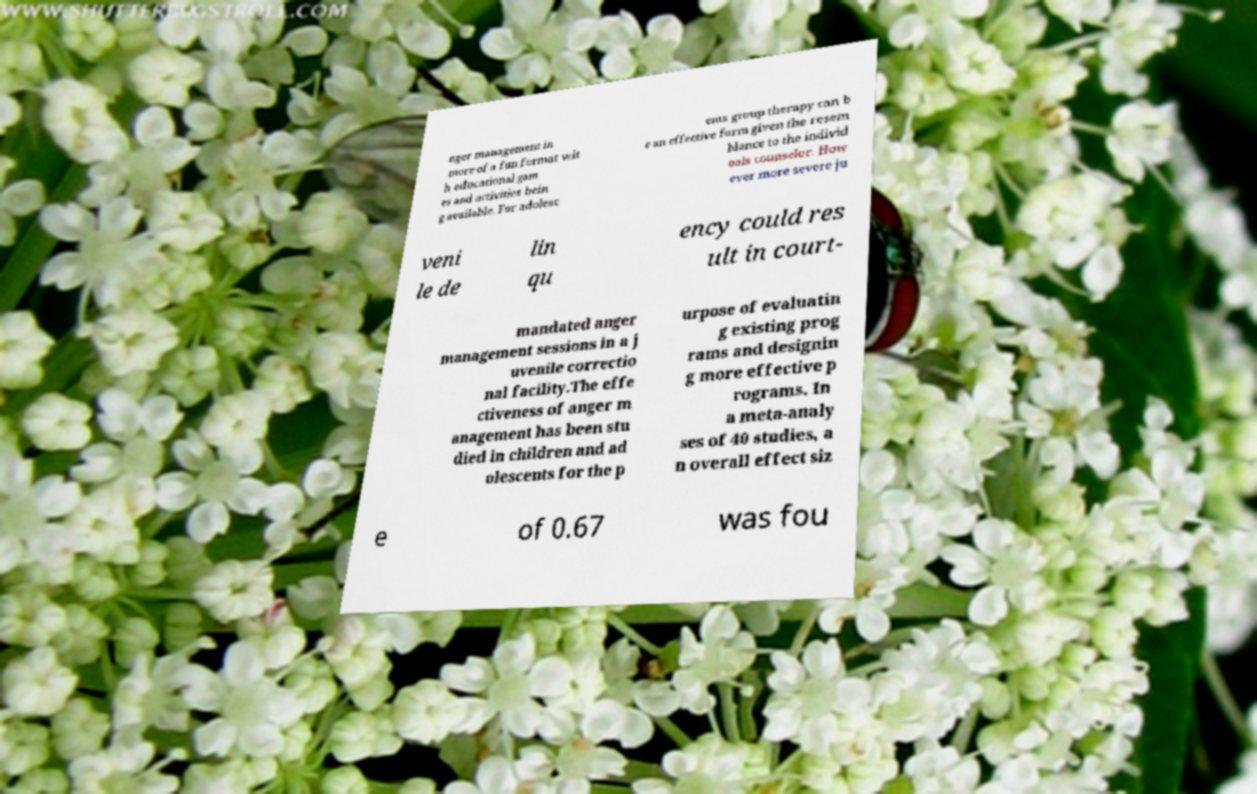Could you extract and type out the text from this image? nger management in more of a fun format wit h educational gam es and activities bein g available. For adolesc ents group therapy can b e an effective form given the resem blance to the individ uals counselor. How ever more severe ju veni le de lin qu ency could res ult in court- mandated anger management sessions in a j uvenile correctio nal facility.The effe ctiveness of anger m anagement has been stu died in children and ad olescents for the p urpose of evaluatin g existing prog rams and designin g more effective p rograms. In a meta-analy ses of 40 studies, a n overall effect siz e of 0.67 was fou 